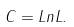Convert formula to latex. <formula><loc_0><loc_0><loc_500><loc_500>C = L n L .</formula> 